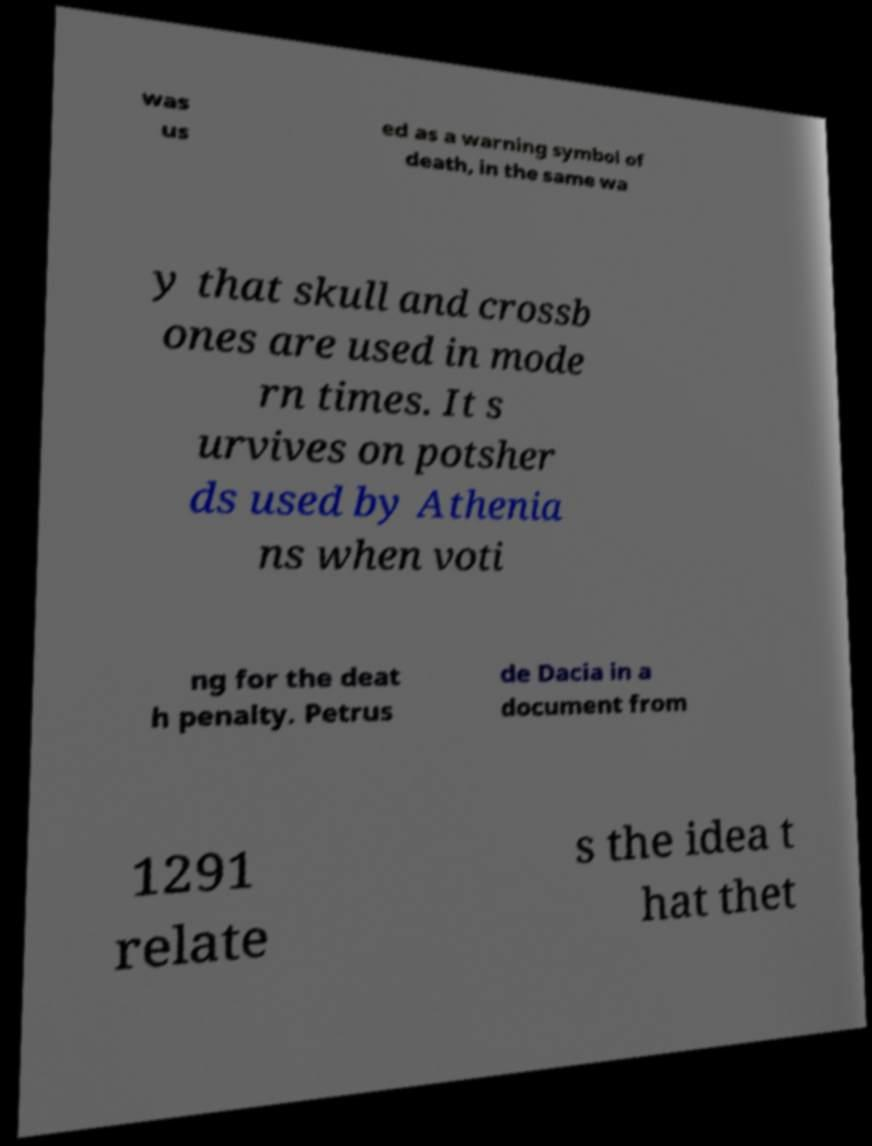For documentation purposes, I need the text within this image transcribed. Could you provide that? was us ed as a warning symbol of death, in the same wa y that skull and crossb ones are used in mode rn times. It s urvives on potsher ds used by Athenia ns when voti ng for the deat h penalty. Petrus de Dacia in a document from 1291 relate s the idea t hat thet 